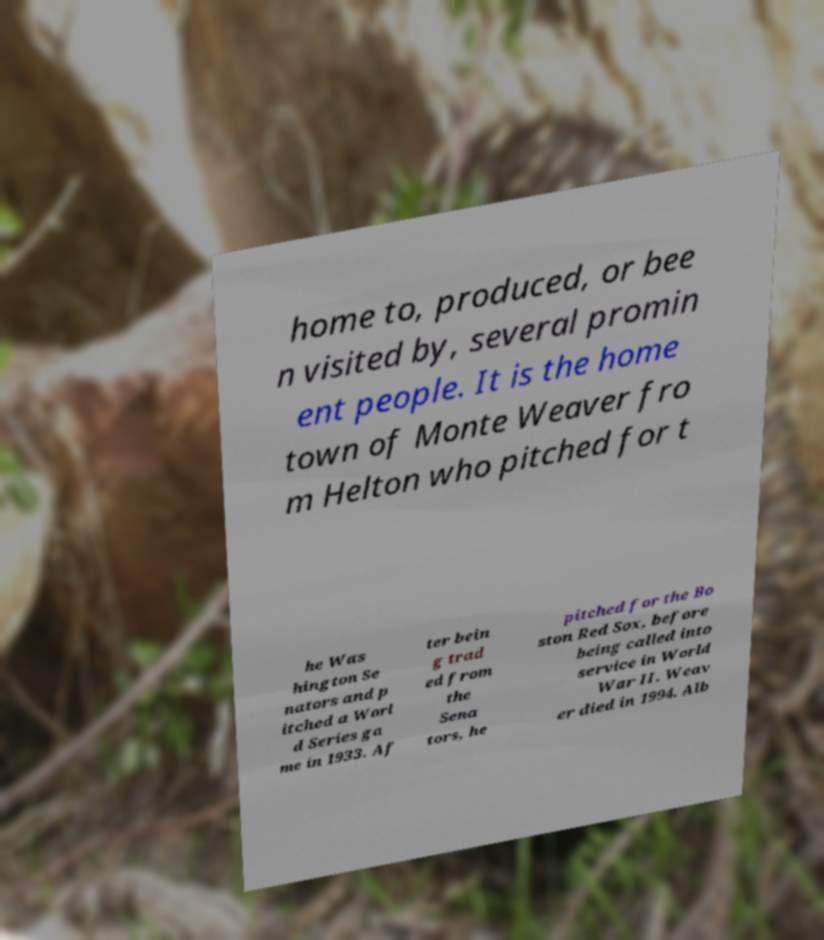For documentation purposes, I need the text within this image transcribed. Could you provide that? home to, produced, or bee n visited by, several promin ent people. It is the home town of Monte Weaver fro m Helton who pitched for t he Was hington Se nators and p itched a Worl d Series ga me in 1933. Af ter bein g trad ed from the Sena tors, he pitched for the Bo ston Red Sox, before being called into service in World War II. Weav er died in 1994. Alb 